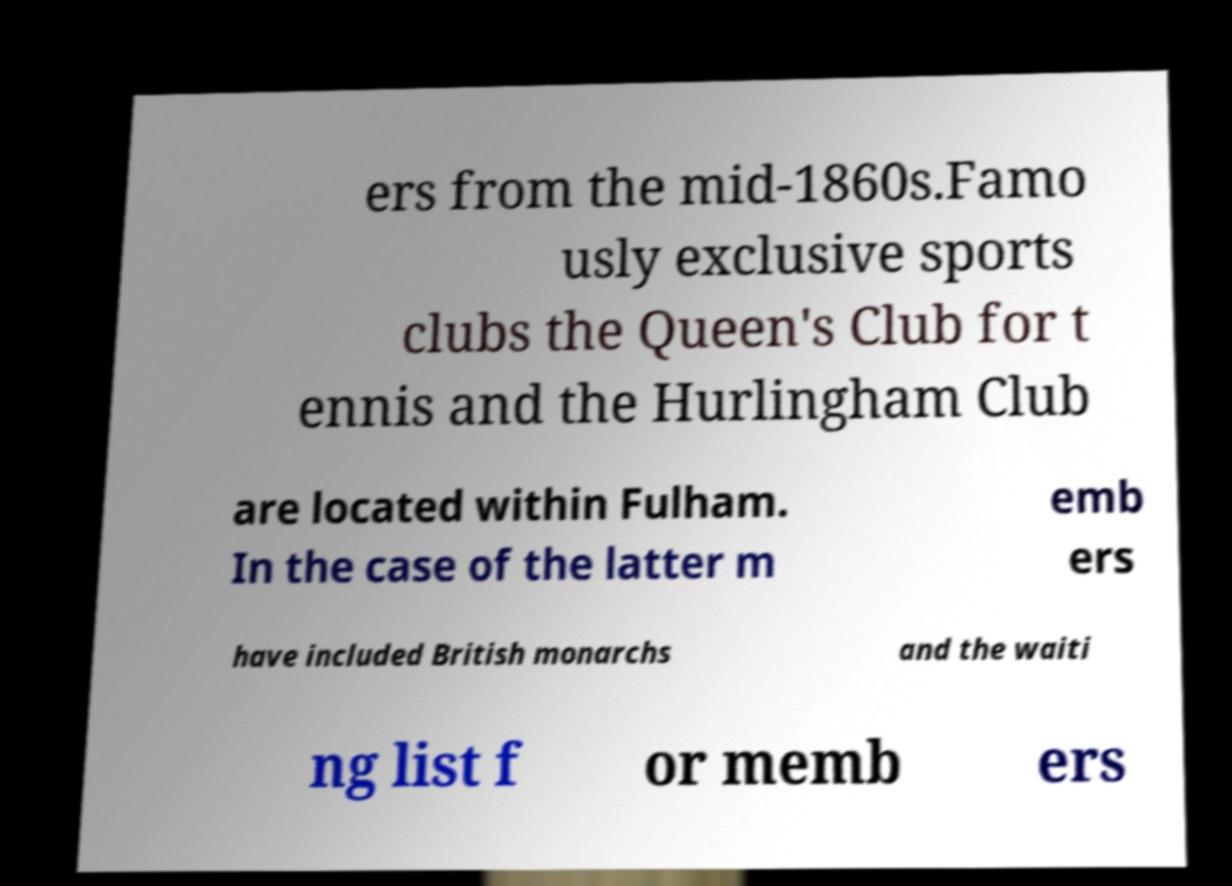Please read and relay the text visible in this image. What does it say? ers from the mid-1860s.Famo usly exclusive sports clubs the Queen's Club for t ennis and the Hurlingham Club are located within Fulham. In the case of the latter m emb ers have included British monarchs and the waiti ng list f or memb ers 